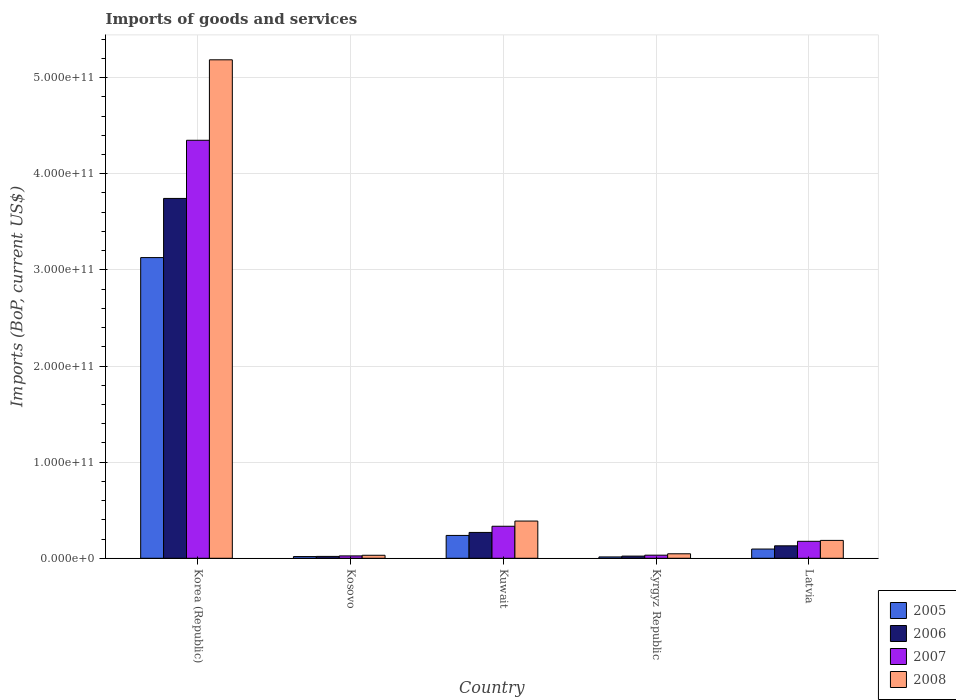How many different coloured bars are there?
Make the answer very short. 4. How many groups of bars are there?
Your answer should be compact. 5. How many bars are there on the 5th tick from the left?
Provide a succinct answer. 4. What is the label of the 3rd group of bars from the left?
Make the answer very short. Kuwait. What is the amount spent on imports in 2006 in Kyrgyz Republic?
Your answer should be compact. 2.25e+09. Across all countries, what is the maximum amount spent on imports in 2007?
Your response must be concise. 4.35e+11. Across all countries, what is the minimum amount spent on imports in 2006?
Your answer should be compact. 1.95e+09. In which country was the amount spent on imports in 2007 minimum?
Your response must be concise. Kosovo. What is the total amount spent on imports in 2008 in the graph?
Provide a short and direct response. 5.84e+11. What is the difference between the amount spent on imports in 2008 in Korea (Republic) and that in Kosovo?
Your answer should be very brief. 5.15e+11. What is the difference between the amount spent on imports in 2008 in Kyrgyz Republic and the amount spent on imports in 2005 in Kuwait?
Give a very brief answer. -1.91e+1. What is the average amount spent on imports in 2005 per country?
Make the answer very short. 6.99e+1. What is the difference between the amount spent on imports of/in 2006 and amount spent on imports of/in 2007 in Kyrgyz Republic?
Make the answer very short. -9.66e+08. In how many countries, is the amount spent on imports in 2006 greater than 520000000000 US$?
Offer a very short reply. 0. What is the ratio of the amount spent on imports in 2005 in Korea (Republic) to that in Kosovo?
Your response must be concise. 177.28. Is the difference between the amount spent on imports in 2006 in Korea (Republic) and Kyrgyz Republic greater than the difference between the amount spent on imports in 2007 in Korea (Republic) and Kyrgyz Republic?
Ensure brevity in your answer.  No. What is the difference between the highest and the second highest amount spent on imports in 2005?
Your answer should be very brief. 2.89e+11. What is the difference between the highest and the lowest amount spent on imports in 2008?
Your answer should be very brief. 5.15e+11. In how many countries, is the amount spent on imports in 2006 greater than the average amount spent on imports in 2006 taken over all countries?
Make the answer very short. 1. Is the sum of the amount spent on imports in 2008 in Kosovo and Kyrgyz Republic greater than the maximum amount spent on imports in 2006 across all countries?
Give a very brief answer. No. What does the 3rd bar from the right in Kuwait represents?
Offer a terse response. 2006. Is it the case that in every country, the sum of the amount spent on imports in 2005 and amount spent on imports in 2008 is greater than the amount spent on imports in 2006?
Provide a short and direct response. Yes. How many bars are there?
Your answer should be compact. 20. How many countries are there in the graph?
Keep it short and to the point. 5. What is the difference between two consecutive major ticks on the Y-axis?
Offer a terse response. 1.00e+11. Are the values on the major ticks of Y-axis written in scientific E-notation?
Keep it short and to the point. Yes. Where does the legend appear in the graph?
Your answer should be very brief. Bottom right. How are the legend labels stacked?
Offer a terse response. Vertical. What is the title of the graph?
Provide a succinct answer. Imports of goods and services. What is the label or title of the X-axis?
Provide a succinct answer. Country. What is the label or title of the Y-axis?
Your response must be concise. Imports (BoP, current US$). What is the Imports (BoP, current US$) of 2005 in Korea (Republic)?
Your response must be concise. 3.13e+11. What is the Imports (BoP, current US$) of 2006 in Korea (Republic)?
Offer a very short reply. 3.74e+11. What is the Imports (BoP, current US$) in 2007 in Korea (Republic)?
Give a very brief answer. 4.35e+11. What is the Imports (BoP, current US$) of 2008 in Korea (Republic)?
Give a very brief answer. 5.19e+11. What is the Imports (BoP, current US$) in 2005 in Kosovo?
Offer a very short reply. 1.76e+09. What is the Imports (BoP, current US$) in 2006 in Kosovo?
Your answer should be compact. 1.95e+09. What is the Imports (BoP, current US$) of 2007 in Kosovo?
Your answer should be very brief. 2.46e+09. What is the Imports (BoP, current US$) in 2008 in Kosovo?
Your answer should be compact. 3.12e+09. What is the Imports (BoP, current US$) in 2005 in Kuwait?
Keep it short and to the point. 2.38e+1. What is the Imports (BoP, current US$) in 2006 in Kuwait?
Your answer should be compact. 2.69e+1. What is the Imports (BoP, current US$) of 2007 in Kuwait?
Your response must be concise. 3.33e+1. What is the Imports (BoP, current US$) in 2008 in Kuwait?
Offer a very short reply. 3.87e+1. What is the Imports (BoP, current US$) in 2005 in Kyrgyz Republic?
Ensure brevity in your answer.  1.40e+09. What is the Imports (BoP, current US$) of 2006 in Kyrgyz Republic?
Keep it short and to the point. 2.25e+09. What is the Imports (BoP, current US$) in 2007 in Kyrgyz Republic?
Give a very brief answer. 3.22e+09. What is the Imports (BoP, current US$) of 2008 in Kyrgyz Republic?
Make the answer very short. 4.66e+09. What is the Imports (BoP, current US$) of 2005 in Latvia?
Provide a succinct answer. 9.60e+09. What is the Imports (BoP, current US$) of 2006 in Latvia?
Make the answer very short. 1.29e+1. What is the Imports (BoP, current US$) of 2007 in Latvia?
Offer a very short reply. 1.76e+1. What is the Imports (BoP, current US$) of 2008 in Latvia?
Provide a short and direct response. 1.86e+1. Across all countries, what is the maximum Imports (BoP, current US$) in 2005?
Your answer should be compact. 3.13e+11. Across all countries, what is the maximum Imports (BoP, current US$) of 2006?
Keep it short and to the point. 3.74e+11. Across all countries, what is the maximum Imports (BoP, current US$) in 2007?
Provide a short and direct response. 4.35e+11. Across all countries, what is the maximum Imports (BoP, current US$) of 2008?
Make the answer very short. 5.19e+11. Across all countries, what is the minimum Imports (BoP, current US$) of 2005?
Give a very brief answer. 1.40e+09. Across all countries, what is the minimum Imports (BoP, current US$) of 2006?
Keep it short and to the point. 1.95e+09. Across all countries, what is the minimum Imports (BoP, current US$) of 2007?
Ensure brevity in your answer.  2.46e+09. Across all countries, what is the minimum Imports (BoP, current US$) of 2008?
Ensure brevity in your answer.  3.12e+09. What is the total Imports (BoP, current US$) of 2005 in the graph?
Provide a short and direct response. 3.49e+11. What is the total Imports (BoP, current US$) in 2006 in the graph?
Make the answer very short. 4.18e+11. What is the total Imports (BoP, current US$) in 2007 in the graph?
Make the answer very short. 4.91e+11. What is the total Imports (BoP, current US$) of 2008 in the graph?
Your answer should be compact. 5.84e+11. What is the difference between the Imports (BoP, current US$) in 2005 in Korea (Republic) and that in Kosovo?
Make the answer very short. 3.11e+11. What is the difference between the Imports (BoP, current US$) of 2006 in Korea (Republic) and that in Kosovo?
Your response must be concise. 3.72e+11. What is the difference between the Imports (BoP, current US$) in 2007 in Korea (Republic) and that in Kosovo?
Offer a terse response. 4.32e+11. What is the difference between the Imports (BoP, current US$) of 2008 in Korea (Republic) and that in Kosovo?
Your response must be concise. 5.15e+11. What is the difference between the Imports (BoP, current US$) in 2005 in Korea (Republic) and that in Kuwait?
Make the answer very short. 2.89e+11. What is the difference between the Imports (BoP, current US$) in 2006 in Korea (Republic) and that in Kuwait?
Ensure brevity in your answer.  3.47e+11. What is the difference between the Imports (BoP, current US$) in 2007 in Korea (Republic) and that in Kuwait?
Ensure brevity in your answer.  4.02e+11. What is the difference between the Imports (BoP, current US$) in 2008 in Korea (Republic) and that in Kuwait?
Provide a short and direct response. 4.80e+11. What is the difference between the Imports (BoP, current US$) in 2005 in Korea (Republic) and that in Kyrgyz Republic?
Your answer should be very brief. 3.11e+11. What is the difference between the Imports (BoP, current US$) of 2006 in Korea (Republic) and that in Kyrgyz Republic?
Make the answer very short. 3.72e+11. What is the difference between the Imports (BoP, current US$) in 2007 in Korea (Republic) and that in Kyrgyz Republic?
Make the answer very short. 4.32e+11. What is the difference between the Imports (BoP, current US$) of 2008 in Korea (Republic) and that in Kyrgyz Republic?
Offer a very short reply. 5.14e+11. What is the difference between the Imports (BoP, current US$) of 2005 in Korea (Republic) and that in Latvia?
Provide a short and direct response. 3.03e+11. What is the difference between the Imports (BoP, current US$) of 2006 in Korea (Republic) and that in Latvia?
Your answer should be very brief. 3.61e+11. What is the difference between the Imports (BoP, current US$) of 2007 in Korea (Republic) and that in Latvia?
Offer a terse response. 4.17e+11. What is the difference between the Imports (BoP, current US$) of 2008 in Korea (Republic) and that in Latvia?
Your response must be concise. 5.00e+11. What is the difference between the Imports (BoP, current US$) of 2005 in Kosovo and that in Kuwait?
Make the answer very short. -2.20e+1. What is the difference between the Imports (BoP, current US$) of 2006 in Kosovo and that in Kuwait?
Offer a very short reply. -2.49e+1. What is the difference between the Imports (BoP, current US$) of 2007 in Kosovo and that in Kuwait?
Your answer should be very brief. -3.08e+1. What is the difference between the Imports (BoP, current US$) in 2008 in Kosovo and that in Kuwait?
Keep it short and to the point. -3.56e+1. What is the difference between the Imports (BoP, current US$) of 2005 in Kosovo and that in Kyrgyz Republic?
Make the answer very short. 3.69e+08. What is the difference between the Imports (BoP, current US$) of 2006 in Kosovo and that in Kyrgyz Republic?
Provide a short and direct response. -3.02e+08. What is the difference between the Imports (BoP, current US$) in 2007 in Kosovo and that in Kyrgyz Republic?
Give a very brief answer. -7.58e+08. What is the difference between the Imports (BoP, current US$) in 2008 in Kosovo and that in Kyrgyz Republic?
Keep it short and to the point. -1.54e+09. What is the difference between the Imports (BoP, current US$) of 2005 in Kosovo and that in Latvia?
Offer a terse response. -7.83e+09. What is the difference between the Imports (BoP, current US$) in 2006 in Kosovo and that in Latvia?
Your answer should be very brief. -1.10e+1. What is the difference between the Imports (BoP, current US$) in 2007 in Kosovo and that in Latvia?
Give a very brief answer. -1.52e+1. What is the difference between the Imports (BoP, current US$) in 2008 in Kosovo and that in Latvia?
Provide a short and direct response. -1.55e+1. What is the difference between the Imports (BoP, current US$) in 2005 in Kuwait and that in Kyrgyz Republic?
Give a very brief answer. 2.24e+1. What is the difference between the Imports (BoP, current US$) of 2006 in Kuwait and that in Kyrgyz Republic?
Keep it short and to the point. 2.46e+1. What is the difference between the Imports (BoP, current US$) of 2007 in Kuwait and that in Kyrgyz Republic?
Offer a very short reply. 3.01e+1. What is the difference between the Imports (BoP, current US$) of 2008 in Kuwait and that in Kyrgyz Republic?
Offer a very short reply. 3.41e+1. What is the difference between the Imports (BoP, current US$) of 2005 in Kuwait and that in Latvia?
Your response must be concise. 1.42e+1. What is the difference between the Imports (BoP, current US$) of 2006 in Kuwait and that in Latvia?
Provide a short and direct response. 1.39e+1. What is the difference between the Imports (BoP, current US$) of 2007 in Kuwait and that in Latvia?
Provide a short and direct response. 1.57e+1. What is the difference between the Imports (BoP, current US$) of 2008 in Kuwait and that in Latvia?
Your answer should be very brief. 2.01e+1. What is the difference between the Imports (BoP, current US$) in 2005 in Kyrgyz Republic and that in Latvia?
Offer a terse response. -8.20e+09. What is the difference between the Imports (BoP, current US$) of 2006 in Kyrgyz Republic and that in Latvia?
Offer a terse response. -1.07e+1. What is the difference between the Imports (BoP, current US$) in 2007 in Kyrgyz Republic and that in Latvia?
Give a very brief answer. -1.44e+1. What is the difference between the Imports (BoP, current US$) of 2008 in Kyrgyz Republic and that in Latvia?
Your answer should be very brief. -1.39e+1. What is the difference between the Imports (BoP, current US$) of 2005 in Korea (Republic) and the Imports (BoP, current US$) of 2006 in Kosovo?
Give a very brief answer. 3.11e+11. What is the difference between the Imports (BoP, current US$) of 2005 in Korea (Republic) and the Imports (BoP, current US$) of 2007 in Kosovo?
Provide a succinct answer. 3.10e+11. What is the difference between the Imports (BoP, current US$) of 2005 in Korea (Republic) and the Imports (BoP, current US$) of 2008 in Kosovo?
Offer a terse response. 3.10e+11. What is the difference between the Imports (BoP, current US$) in 2006 in Korea (Republic) and the Imports (BoP, current US$) in 2007 in Kosovo?
Your response must be concise. 3.72e+11. What is the difference between the Imports (BoP, current US$) in 2006 in Korea (Republic) and the Imports (BoP, current US$) in 2008 in Kosovo?
Provide a succinct answer. 3.71e+11. What is the difference between the Imports (BoP, current US$) in 2007 in Korea (Republic) and the Imports (BoP, current US$) in 2008 in Kosovo?
Ensure brevity in your answer.  4.32e+11. What is the difference between the Imports (BoP, current US$) in 2005 in Korea (Republic) and the Imports (BoP, current US$) in 2006 in Kuwait?
Keep it short and to the point. 2.86e+11. What is the difference between the Imports (BoP, current US$) of 2005 in Korea (Republic) and the Imports (BoP, current US$) of 2007 in Kuwait?
Give a very brief answer. 2.79e+11. What is the difference between the Imports (BoP, current US$) of 2005 in Korea (Republic) and the Imports (BoP, current US$) of 2008 in Kuwait?
Ensure brevity in your answer.  2.74e+11. What is the difference between the Imports (BoP, current US$) in 2006 in Korea (Republic) and the Imports (BoP, current US$) in 2007 in Kuwait?
Provide a short and direct response. 3.41e+11. What is the difference between the Imports (BoP, current US$) in 2006 in Korea (Republic) and the Imports (BoP, current US$) in 2008 in Kuwait?
Make the answer very short. 3.36e+11. What is the difference between the Imports (BoP, current US$) of 2007 in Korea (Republic) and the Imports (BoP, current US$) of 2008 in Kuwait?
Provide a succinct answer. 3.96e+11. What is the difference between the Imports (BoP, current US$) in 2005 in Korea (Republic) and the Imports (BoP, current US$) in 2006 in Kyrgyz Republic?
Your answer should be compact. 3.11e+11. What is the difference between the Imports (BoP, current US$) in 2005 in Korea (Republic) and the Imports (BoP, current US$) in 2007 in Kyrgyz Republic?
Your response must be concise. 3.10e+11. What is the difference between the Imports (BoP, current US$) in 2005 in Korea (Republic) and the Imports (BoP, current US$) in 2008 in Kyrgyz Republic?
Provide a succinct answer. 3.08e+11. What is the difference between the Imports (BoP, current US$) of 2006 in Korea (Republic) and the Imports (BoP, current US$) of 2007 in Kyrgyz Republic?
Your response must be concise. 3.71e+11. What is the difference between the Imports (BoP, current US$) of 2006 in Korea (Republic) and the Imports (BoP, current US$) of 2008 in Kyrgyz Republic?
Keep it short and to the point. 3.70e+11. What is the difference between the Imports (BoP, current US$) of 2007 in Korea (Republic) and the Imports (BoP, current US$) of 2008 in Kyrgyz Republic?
Give a very brief answer. 4.30e+11. What is the difference between the Imports (BoP, current US$) in 2005 in Korea (Republic) and the Imports (BoP, current US$) in 2006 in Latvia?
Your answer should be compact. 3.00e+11. What is the difference between the Imports (BoP, current US$) in 2005 in Korea (Republic) and the Imports (BoP, current US$) in 2007 in Latvia?
Your answer should be very brief. 2.95e+11. What is the difference between the Imports (BoP, current US$) of 2005 in Korea (Republic) and the Imports (BoP, current US$) of 2008 in Latvia?
Offer a very short reply. 2.94e+11. What is the difference between the Imports (BoP, current US$) of 2006 in Korea (Republic) and the Imports (BoP, current US$) of 2007 in Latvia?
Make the answer very short. 3.57e+11. What is the difference between the Imports (BoP, current US$) in 2006 in Korea (Republic) and the Imports (BoP, current US$) in 2008 in Latvia?
Offer a very short reply. 3.56e+11. What is the difference between the Imports (BoP, current US$) in 2007 in Korea (Republic) and the Imports (BoP, current US$) in 2008 in Latvia?
Your answer should be compact. 4.16e+11. What is the difference between the Imports (BoP, current US$) in 2005 in Kosovo and the Imports (BoP, current US$) in 2006 in Kuwait?
Give a very brief answer. -2.51e+1. What is the difference between the Imports (BoP, current US$) of 2005 in Kosovo and the Imports (BoP, current US$) of 2007 in Kuwait?
Make the answer very short. -3.15e+1. What is the difference between the Imports (BoP, current US$) of 2005 in Kosovo and the Imports (BoP, current US$) of 2008 in Kuwait?
Your answer should be very brief. -3.70e+1. What is the difference between the Imports (BoP, current US$) of 2006 in Kosovo and the Imports (BoP, current US$) of 2007 in Kuwait?
Your response must be concise. -3.14e+1. What is the difference between the Imports (BoP, current US$) of 2006 in Kosovo and the Imports (BoP, current US$) of 2008 in Kuwait?
Give a very brief answer. -3.68e+1. What is the difference between the Imports (BoP, current US$) in 2007 in Kosovo and the Imports (BoP, current US$) in 2008 in Kuwait?
Provide a short and direct response. -3.63e+1. What is the difference between the Imports (BoP, current US$) in 2005 in Kosovo and the Imports (BoP, current US$) in 2006 in Kyrgyz Republic?
Your response must be concise. -4.88e+08. What is the difference between the Imports (BoP, current US$) of 2005 in Kosovo and the Imports (BoP, current US$) of 2007 in Kyrgyz Republic?
Make the answer very short. -1.45e+09. What is the difference between the Imports (BoP, current US$) in 2005 in Kosovo and the Imports (BoP, current US$) in 2008 in Kyrgyz Republic?
Provide a succinct answer. -2.90e+09. What is the difference between the Imports (BoP, current US$) in 2006 in Kosovo and the Imports (BoP, current US$) in 2007 in Kyrgyz Republic?
Your response must be concise. -1.27e+09. What is the difference between the Imports (BoP, current US$) of 2006 in Kosovo and the Imports (BoP, current US$) of 2008 in Kyrgyz Republic?
Offer a very short reply. -2.71e+09. What is the difference between the Imports (BoP, current US$) in 2007 in Kosovo and the Imports (BoP, current US$) in 2008 in Kyrgyz Republic?
Your answer should be compact. -2.20e+09. What is the difference between the Imports (BoP, current US$) of 2005 in Kosovo and the Imports (BoP, current US$) of 2006 in Latvia?
Provide a short and direct response. -1.12e+1. What is the difference between the Imports (BoP, current US$) of 2005 in Kosovo and the Imports (BoP, current US$) of 2007 in Latvia?
Offer a terse response. -1.59e+1. What is the difference between the Imports (BoP, current US$) of 2005 in Kosovo and the Imports (BoP, current US$) of 2008 in Latvia?
Keep it short and to the point. -1.68e+1. What is the difference between the Imports (BoP, current US$) in 2006 in Kosovo and the Imports (BoP, current US$) in 2007 in Latvia?
Give a very brief answer. -1.57e+1. What is the difference between the Imports (BoP, current US$) of 2006 in Kosovo and the Imports (BoP, current US$) of 2008 in Latvia?
Your response must be concise. -1.66e+1. What is the difference between the Imports (BoP, current US$) of 2007 in Kosovo and the Imports (BoP, current US$) of 2008 in Latvia?
Provide a succinct answer. -1.61e+1. What is the difference between the Imports (BoP, current US$) in 2005 in Kuwait and the Imports (BoP, current US$) in 2006 in Kyrgyz Republic?
Offer a terse response. 2.15e+1. What is the difference between the Imports (BoP, current US$) in 2005 in Kuwait and the Imports (BoP, current US$) in 2007 in Kyrgyz Republic?
Provide a succinct answer. 2.06e+1. What is the difference between the Imports (BoP, current US$) in 2005 in Kuwait and the Imports (BoP, current US$) in 2008 in Kyrgyz Republic?
Your answer should be compact. 1.91e+1. What is the difference between the Imports (BoP, current US$) in 2006 in Kuwait and the Imports (BoP, current US$) in 2007 in Kyrgyz Republic?
Offer a very short reply. 2.37e+1. What is the difference between the Imports (BoP, current US$) of 2006 in Kuwait and the Imports (BoP, current US$) of 2008 in Kyrgyz Republic?
Offer a very short reply. 2.22e+1. What is the difference between the Imports (BoP, current US$) in 2007 in Kuwait and the Imports (BoP, current US$) in 2008 in Kyrgyz Republic?
Make the answer very short. 2.86e+1. What is the difference between the Imports (BoP, current US$) of 2005 in Kuwait and the Imports (BoP, current US$) of 2006 in Latvia?
Provide a short and direct response. 1.08e+1. What is the difference between the Imports (BoP, current US$) of 2005 in Kuwait and the Imports (BoP, current US$) of 2007 in Latvia?
Provide a short and direct response. 6.12e+09. What is the difference between the Imports (BoP, current US$) in 2005 in Kuwait and the Imports (BoP, current US$) in 2008 in Latvia?
Ensure brevity in your answer.  5.17e+09. What is the difference between the Imports (BoP, current US$) of 2006 in Kuwait and the Imports (BoP, current US$) of 2007 in Latvia?
Ensure brevity in your answer.  9.23e+09. What is the difference between the Imports (BoP, current US$) in 2006 in Kuwait and the Imports (BoP, current US$) in 2008 in Latvia?
Provide a short and direct response. 8.28e+09. What is the difference between the Imports (BoP, current US$) of 2007 in Kuwait and the Imports (BoP, current US$) of 2008 in Latvia?
Give a very brief answer. 1.47e+1. What is the difference between the Imports (BoP, current US$) of 2005 in Kyrgyz Republic and the Imports (BoP, current US$) of 2006 in Latvia?
Offer a very short reply. -1.15e+1. What is the difference between the Imports (BoP, current US$) of 2005 in Kyrgyz Republic and the Imports (BoP, current US$) of 2007 in Latvia?
Make the answer very short. -1.63e+1. What is the difference between the Imports (BoP, current US$) of 2005 in Kyrgyz Republic and the Imports (BoP, current US$) of 2008 in Latvia?
Keep it short and to the point. -1.72e+1. What is the difference between the Imports (BoP, current US$) of 2006 in Kyrgyz Republic and the Imports (BoP, current US$) of 2007 in Latvia?
Ensure brevity in your answer.  -1.54e+1. What is the difference between the Imports (BoP, current US$) of 2006 in Kyrgyz Republic and the Imports (BoP, current US$) of 2008 in Latvia?
Offer a terse response. -1.63e+1. What is the difference between the Imports (BoP, current US$) of 2007 in Kyrgyz Republic and the Imports (BoP, current US$) of 2008 in Latvia?
Provide a short and direct response. -1.54e+1. What is the average Imports (BoP, current US$) in 2005 per country?
Give a very brief answer. 6.99e+1. What is the average Imports (BoP, current US$) of 2006 per country?
Give a very brief answer. 8.37e+1. What is the average Imports (BoP, current US$) in 2007 per country?
Give a very brief answer. 9.83e+1. What is the average Imports (BoP, current US$) of 2008 per country?
Your answer should be compact. 1.17e+11. What is the difference between the Imports (BoP, current US$) of 2005 and Imports (BoP, current US$) of 2006 in Korea (Republic)?
Your answer should be very brief. -6.16e+1. What is the difference between the Imports (BoP, current US$) of 2005 and Imports (BoP, current US$) of 2007 in Korea (Republic)?
Offer a terse response. -1.22e+11. What is the difference between the Imports (BoP, current US$) in 2005 and Imports (BoP, current US$) in 2008 in Korea (Republic)?
Offer a terse response. -2.06e+11. What is the difference between the Imports (BoP, current US$) in 2006 and Imports (BoP, current US$) in 2007 in Korea (Republic)?
Provide a short and direct response. -6.05e+1. What is the difference between the Imports (BoP, current US$) in 2006 and Imports (BoP, current US$) in 2008 in Korea (Republic)?
Keep it short and to the point. -1.44e+11. What is the difference between the Imports (BoP, current US$) of 2007 and Imports (BoP, current US$) of 2008 in Korea (Republic)?
Provide a short and direct response. -8.37e+1. What is the difference between the Imports (BoP, current US$) in 2005 and Imports (BoP, current US$) in 2006 in Kosovo?
Offer a very short reply. -1.86e+08. What is the difference between the Imports (BoP, current US$) of 2005 and Imports (BoP, current US$) of 2007 in Kosovo?
Give a very brief answer. -6.96e+08. What is the difference between the Imports (BoP, current US$) of 2005 and Imports (BoP, current US$) of 2008 in Kosovo?
Provide a short and direct response. -1.36e+09. What is the difference between the Imports (BoP, current US$) of 2006 and Imports (BoP, current US$) of 2007 in Kosovo?
Your answer should be compact. -5.10e+08. What is the difference between the Imports (BoP, current US$) of 2006 and Imports (BoP, current US$) of 2008 in Kosovo?
Make the answer very short. -1.17e+09. What is the difference between the Imports (BoP, current US$) in 2007 and Imports (BoP, current US$) in 2008 in Kosovo?
Provide a short and direct response. -6.61e+08. What is the difference between the Imports (BoP, current US$) of 2005 and Imports (BoP, current US$) of 2006 in Kuwait?
Provide a succinct answer. -3.11e+09. What is the difference between the Imports (BoP, current US$) in 2005 and Imports (BoP, current US$) in 2007 in Kuwait?
Your answer should be compact. -9.54e+09. What is the difference between the Imports (BoP, current US$) of 2005 and Imports (BoP, current US$) of 2008 in Kuwait?
Your answer should be compact. -1.49e+1. What is the difference between the Imports (BoP, current US$) in 2006 and Imports (BoP, current US$) in 2007 in Kuwait?
Make the answer very short. -6.43e+09. What is the difference between the Imports (BoP, current US$) in 2006 and Imports (BoP, current US$) in 2008 in Kuwait?
Your answer should be compact. -1.18e+1. What is the difference between the Imports (BoP, current US$) of 2007 and Imports (BoP, current US$) of 2008 in Kuwait?
Provide a succinct answer. -5.41e+09. What is the difference between the Imports (BoP, current US$) of 2005 and Imports (BoP, current US$) of 2006 in Kyrgyz Republic?
Your answer should be compact. -8.56e+08. What is the difference between the Imports (BoP, current US$) of 2005 and Imports (BoP, current US$) of 2007 in Kyrgyz Republic?
Offer a very short reply. -1.82e+09. What is the difference between the Imports (BoP, current US$) of 2005 and Imports (BoP, current US$) of 2008 in Kyrgyz Republic?
Provide a succinct answer. -3.27e+09. What is the difference between the Imports (BoP, current US$) in 2006 and Imports (BoP, current US$) in 2007 in Kyrgyz Republic?
Your answer should be compact. -9.66e+08. What is the difference between the Imports (BoP, current US$) of 2006 and Imports (BoP, current US$) of 2008 in Kyrgyz Republic?
Keep it short and to the point. -2.41e+09. What is the difference between the Imports (BoP, current US$) of 2007 and Imports (BoP, current US$) of 2008 in Kyrgyz Republic?
Your answer should be compact. -1.45e+09. What is the difference between the Imports (BoP, current US$) of 2005 and Imports (BoP, current US$) of 2006 in Latvia?
Provide a succinct answer. -3.35e+09. What is the difference between the Imports (BoP, current US$) in 2005 and Imports (BoP, current US$) in 2007 in Latvia?
Make the answer very short. -8.05e+09. What is the difference between the Imports (BoP, current US$) in 2005 and Imports (BoP, current US$) in 2008 in Latvia?
Provide a short and direct response. -9.00e+09. What is the difference between the Imports (BoP, current US$) of 2006 and Imports (BoP, current US$) of 2007 in Latvia?
Ensure brevity in your answer.  -4.71e+09. What is the difference between the Imports (BoP, current US$) in 2006 and Imports (BoP, current US$) in 2008 in Latvia?
Give a very brief answer. -5.65e+09. What is the difference between the Imports (BoP, current US$) in 2007 and Imports (BoP, current US$) in 2008 in Latvia?
Your answer should be very brief. -9.45e+08. What is the ratio of the Imports (BoP, current US$) of 2005 in Korea (Republic) to that in Kosovo?
Keep it short and to the point. 177.28. What is the ratio of the Imports (BoP, current US$) in 2006 in Korea (Republic) to that in Kosovo?
Offer a very short reply. 191.97. What is the ratio of the Imports (BoP, current US$) of 2007 in Korea (Republic) to that in Kosovo?
Your response must be concise. 176.75. What is the ratio of the Imports (BoP, current US$) of 2008 in Korea (Republic) to that in Kosovo?
Provide a short and direct response. 166.17. What is the ratio of the Imports (BoP, current US$) of 2005 in Korea (Republic) to that in Kuwait?
Provide a succinct answer. 13.16. What is the ratio of the Imports (BoP, current US$) of 2006 in Korea (Republic) to that in Kuwait?
Your answer should be very brief. 13.93. What is the ratio of the Imports (BoP, current US$) of 2007 in Korea (Republic) to that in Kuwait?
Provide a short and direct response. 13.06. What is the ratio of the Imports (BoP, current US$) of 2008 in Korea (Republic) to that in Kuwait?
Provide a short and direct response. 13.39. What is the ratio of the Imports (BoP, current US$) in 2005 in Korea (Republic) to that in Kyrgyz Republic?
Your response must be concise. 224.1. What is the ratio of the Imports (BoP, current US$) in 2006 in Korea (Republic) to that in Kyrgyz Republic?
Offer a very short reply. 166.22. What is the ratio of the Imports (BoP, current US$) of 2007 in Korea (Republic) to that in Kyrgyz Republic?
Your answer should be compact. 135.13. What is the ratio of the Imports (BoP, current US$) of 2008 in Korea (Republic) to that in Kyrgyz Republic?
Keep it short and to the point. 111.2. What is the ratio of the Imports (BoP, current US$) in 2005 in Korea (Republic) to that in Latvia?
Offer a very short reply. 32.59. What is the ratio of the Imports (BoP, current US$) in 2006 in Korea (Republic) to that in Latvia?
Keep it short and to the point. 28.92. What is the ratio of the Imports (BoP, current US$) in 2007 in Korea (Republic) to that in Latvia?
Your response must be concise. 24.64. What is the ratio of the Imports (BoP, current US$) of 2008 in Korea (Republic) to that in Latvia?
Ensure brevity in your answer.  27.89. What is the ratio of the Imports (BoP, current US$) in 2005 in Kosovo to that in Kuwait?
Ensure brevity in your answer.  0.07. What is the ratio of the Imports (BoP, current US$) of 2006 in Kosovo to that in Kuwait?
Your response must be concise. 0.07. What is the ratio of the Imports (BoP, current US$) of 2007 in Kosovo to that in Kuwait?
Keep it short and to the point. 0.07. What is the ratio of the Imports (BoP, current US$) of 2008 in Kosovo to that in Kuwait?
Provide a short and direct response. 0.08. What is the ratio of the Imports (BoP, current US$) of 2005 in Kosovo to that in Kyrgyz Republic?
Keep it short and to the point. 1.26. What is the ratio of the Imports (BoP, current US$) of 2006 in Kosovo to that in Kyrgyz Republic?
Offer a very short reply. 0.87. What is the ratio of the Imports (BoP, current US$) in 2007 in Kosovo to that in Kyrgyz Republic?
Ensure brevity in your answer.  0.76. What is the ratio of the Imports (BoP, current US$) of 2008 in Kosovo to that in Kyrgyz Republic?
Make the answer very short. 0.67. What is the ratio of the Imports (BoP, current US$) in 2005 in Kosovo to that in Latvia?
Ensure brevity in your answer.  0.18. What is the ratio of the Imports (BoP, current US$) of 2006 in Kosovo to that in Latvia?
Make the answer very short. 0.15. What is the ratio of the Imports (BoP, current US$) of 2007 in Kosovo to that in Latvia?
Your answer should be compact. 0.14. What is the ratio of the Imports (BoP, current US$) in 2008 in Kosovo to that in Latvia?
Your response must be concise. 0.17. What is the ratio of the Imports (BoP, current US$) of 2005 in Kuwait to that in Kyrgyz Republic?
Your response must be concise. 17.03. What is the ratio of the Imports (BoP, current US$) of 2006 in Kuwait to that in Kyrgyz Republic?
Provide a succinct answer. 11.93. What is the ratio of the Imports (BoP, current US$) in 2007 in Kuwait to that in Kyrgyz Republic?
Offer a terse response. 10.35. What is the ratio of the Imports (BoP, current US$) of 2008 in Kuwait to that in Kyrgyz Republic?
Offer a terse response. 8.3. What is the ratio of the Imports (BoP, current US$) in 2005 in Kuwait to that in Latvia?
Keep it short and to the point. 2.48. What is the ratio of the Imports (BoP, current US$) in 2006 in Kuwait to that in Latvia?
Offer a very short reply. 2.08. What is the ratio of the Imports (BoP, current US$) of 2007 in Kuwait to that in Latvia?
Your answer should be very brief. 1.89. What is the ratio of the Imports (BoP, current US$) in 2008 in Kuwait to that in Latvia?
Your answer should be compact. 2.08. What is the ratio of the Imports (BoP, current US$) of 2005 in Kyrgyz Republic to that in Latvia?
Provide a succinct answer. 0.15. What is the ratio of the Imports (BoP, current US$) in 2006 in Kyrgyz Republic to that in Latvia?
Offer a terse response. 0.17. What is the ratio of the Imports (BoP, current US$) of 2007 in Kyrgyz Republic to that in Latvia?
Keep it short and to the point. 0.18. What is the ratio of the Imports (BoP, current US$) of 2008 in Kyrgyz Republic to that in Latvia?
Give a very brief answer. 0.25. What is the difference between the highest and the second highest Imports (BoP, current US$) of 2005?
Your response must be concise. 2.89e+11. What is the difference between the highest and the second highest Imports (BoP, current US$) of 2006?
Your answer should be very brief. 3.47e+11. What is the difference between the highest and the second highest Imports (BoP, current US$) in 2007?
Offer a very short reply. 4.02e+11. What is the difference between the highest and the second highest Imports (BoP, current US$) in 2008?
Your answer should be compact. 4.80e+11. What is the difference between the highest and the lowest Imports (BoP, current US$) in 2005?
Your response must be concise. 3.11e+11. What is the difference between the highest and the lowest Imports (BoP, current US$) in 2006?
Give a very brief answer. 3.72e+11. What is the difference between the highest and the lowest Imports (BoP, current US$) in 2007?
Ensure brevity in your answer.  4.32e+11. What is the difference between the highest and the lowest Imports (BoP, current US$) of 2008?
Provide a short and direct response. 5.15e+11. 